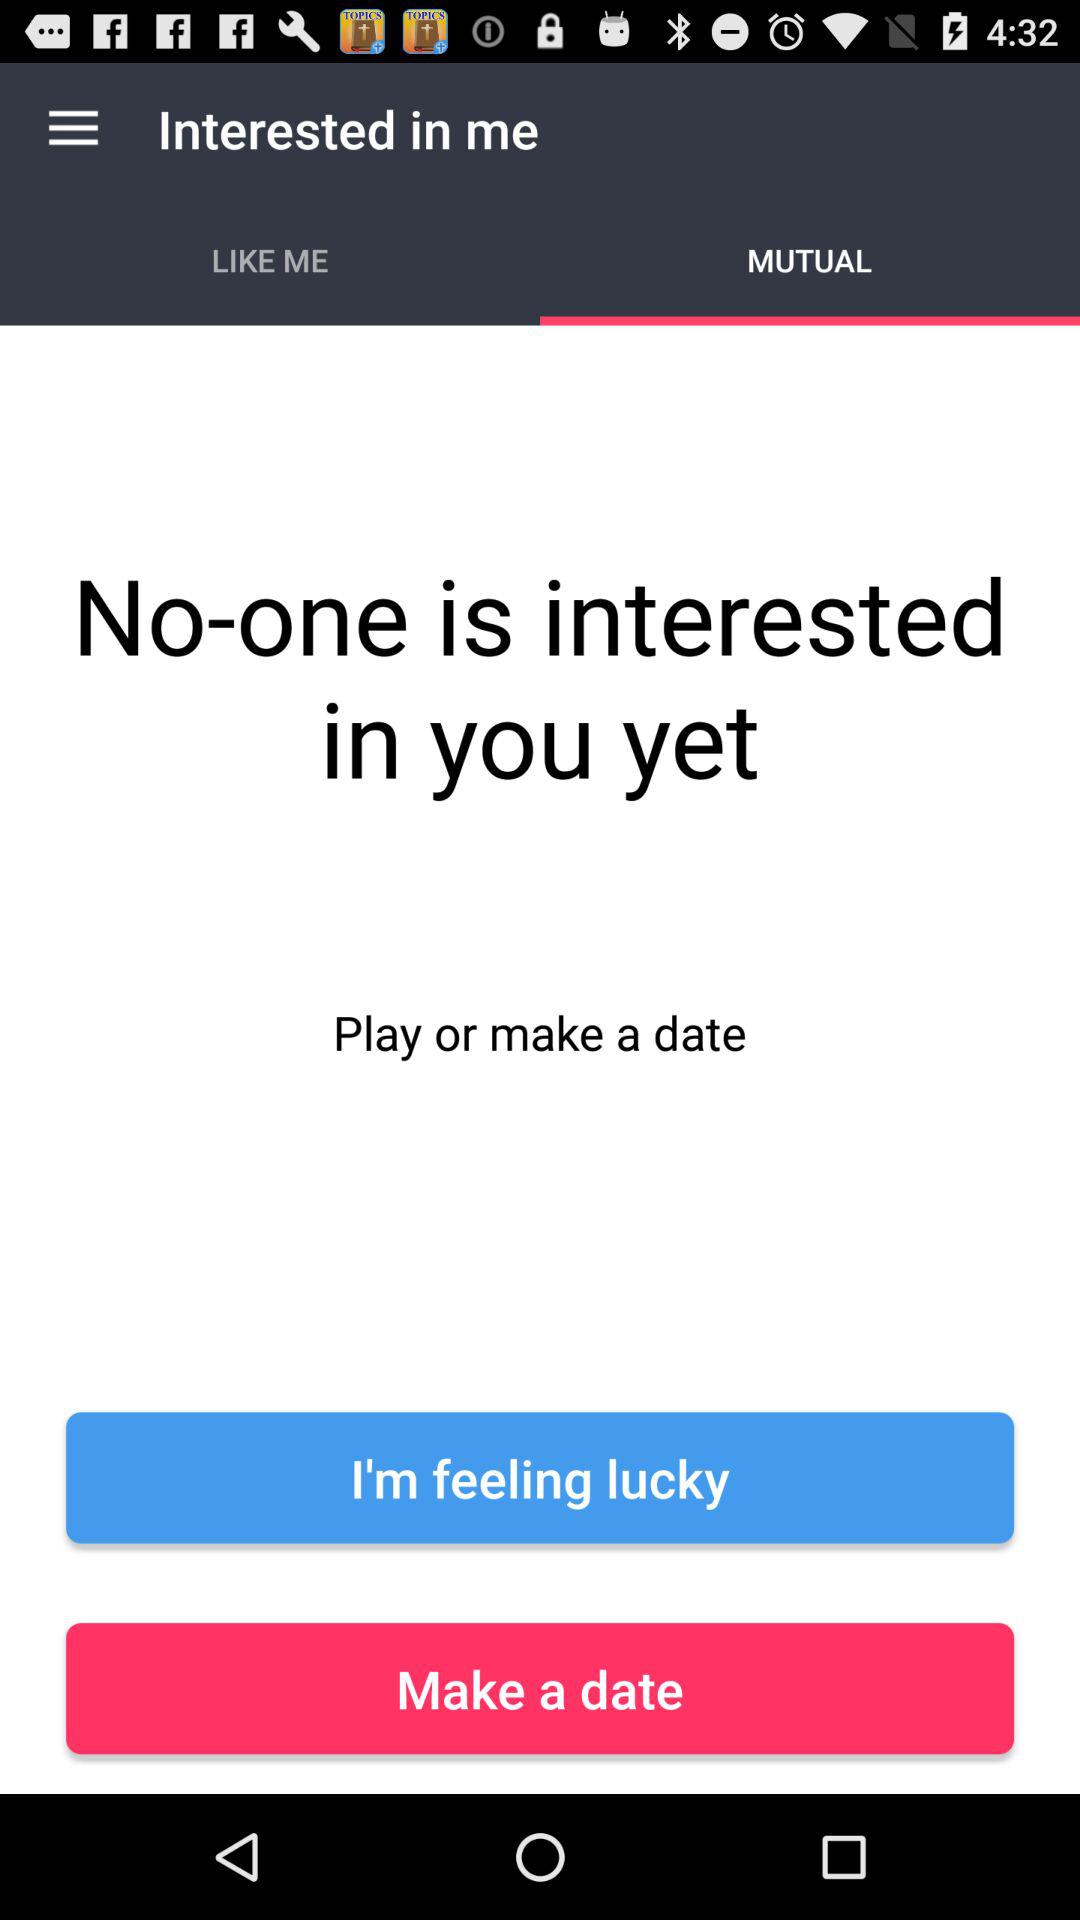Which tab is selected? The selected tab is "MUTUAL". 